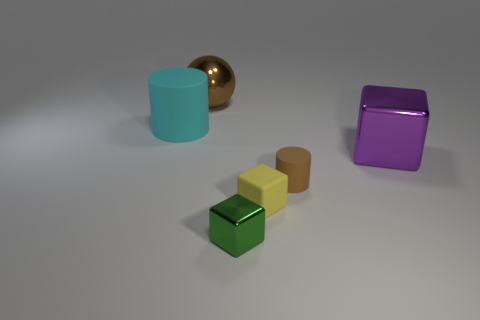Subtract all metal cubes. How many cubes are left? 1 Subtract all spheres. How many objects are left? 5 Subtract all brown cylinders. How many cylinders are left? 1 Subtract 2 blocks. How many blocks are left? 1 Subtract all red cylinders. Subtract all gray blocks. How many cylinders are left? 2 Subtract all yellow cylinders. How many yellow cubes are left? 1 Subtract all tiny metal blocks. Subtract all big rubber things. How many objects are left? 4 Add 5 small cylinders. How many small cylinders are left? 6 Add 5 tiny yellow shiny cubes. How many tiny yellow shiny cubes exist? 5 Add 2 blue things. How many objects exist? 8 